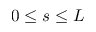<formula> <loc_0><loc_0><loc_500><loc_500>0 \leq s \leq L</formula> 